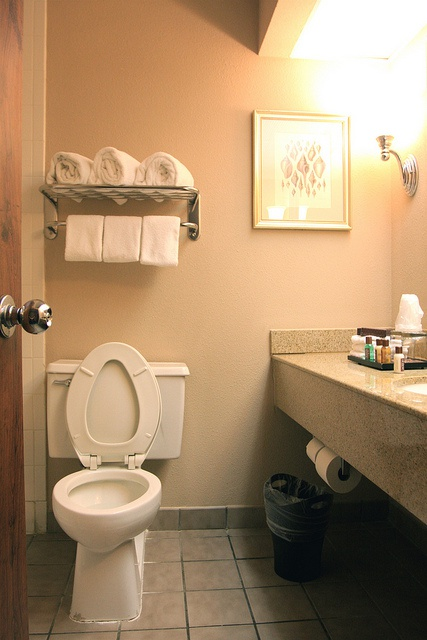Describe the objects in this image and their specific colors. I can see toilet in brown, tan, and gray tones, bottle in brown, tan, and ivory tones, bottle in brown, orange, and maroon tones, sink in beige, tan, brown, and ivory tones, and bottle in brown, maroon, lightgreen, and gray tones in this image. 